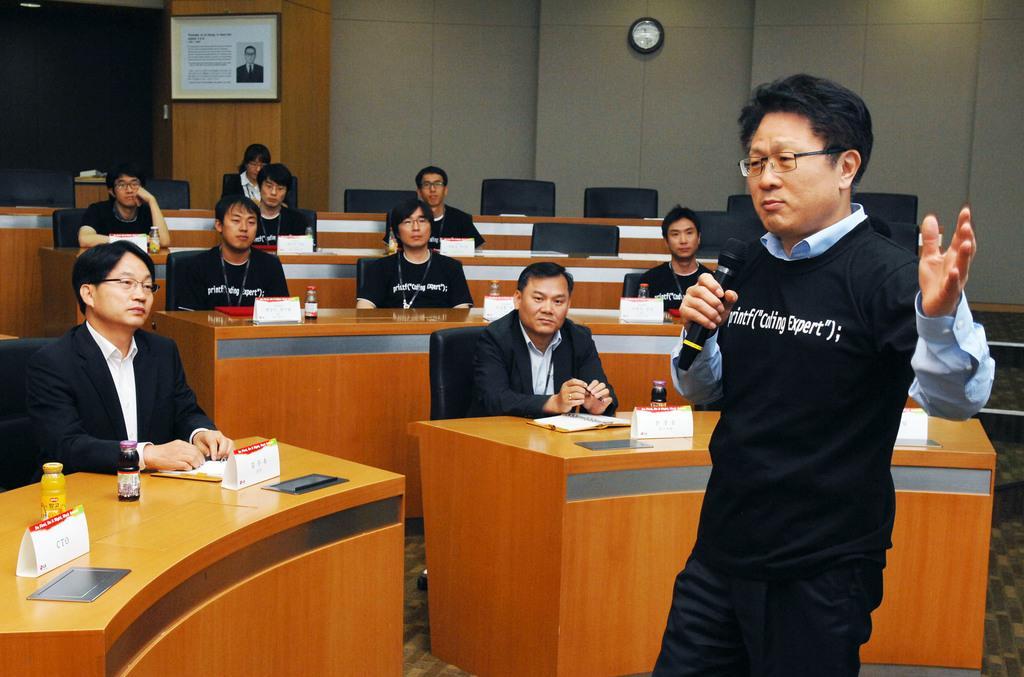Describe this image in one or two sentences. We can see frame and clock on a wall. Here we can see all the persons sitting on chairs in front of a table and on the tables we can see boards, bottles, book. This is a floor. We can see a man wearing spectacles, holding a mike in his hand and talking. 